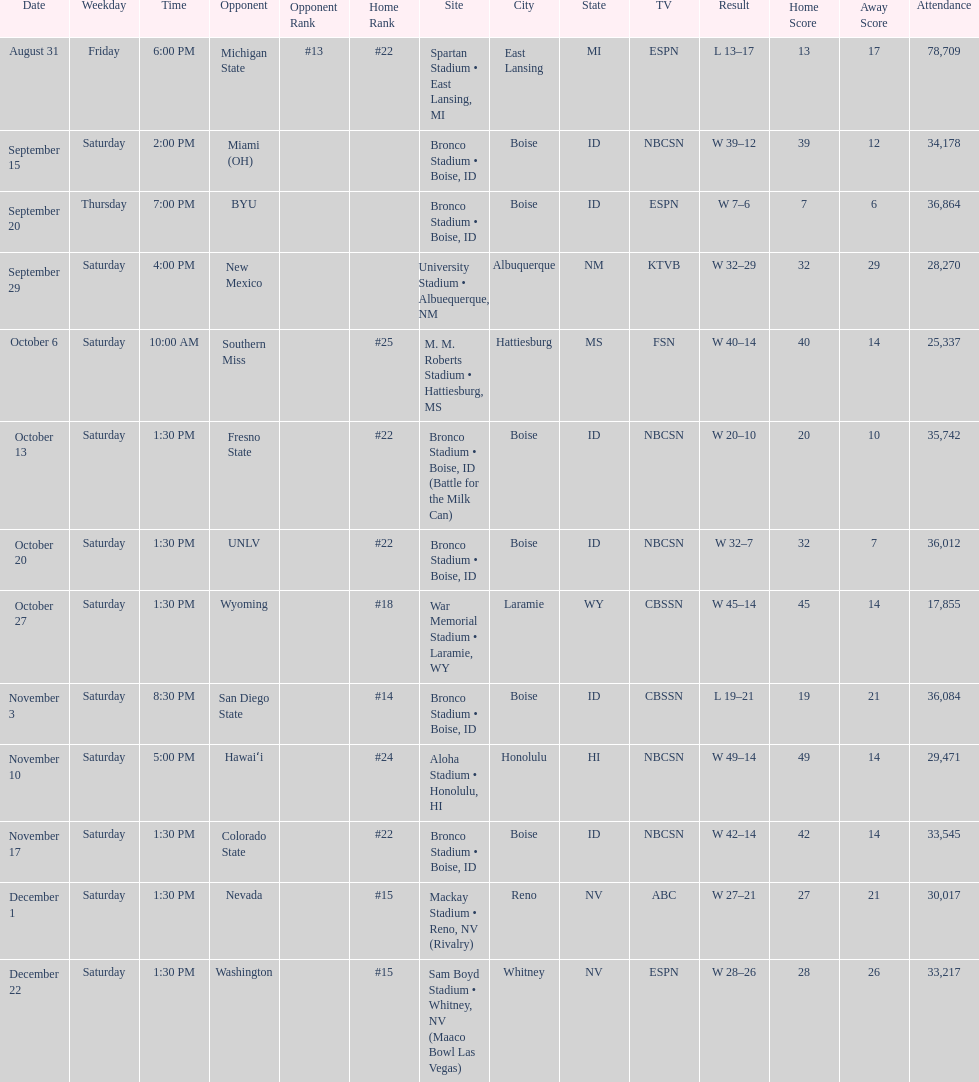What was there top ranked position of the season? #14. 